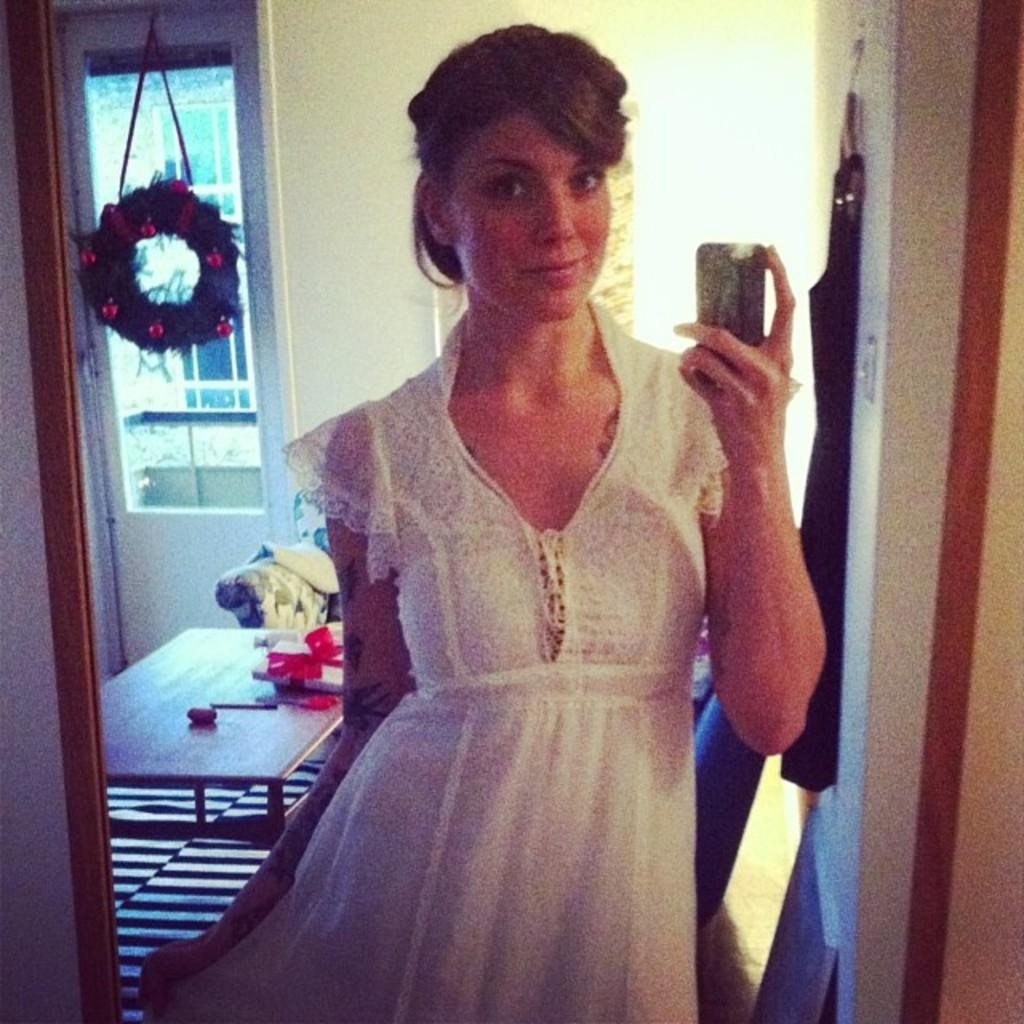What object in the image reflects its surroundings? There is a mirror in the image that reflects its surroundings. What can be seen in the mirror's reflection? The mirror reflects a woman, a table, a sofa, a wall, and a window. Are there any other objects reflected in the mirror? Yes, the mirror reflects other objects as well. How many bikes are leaning against the wall in the image? There are no bikes present in the image; it only features a mirror and its reflections. 